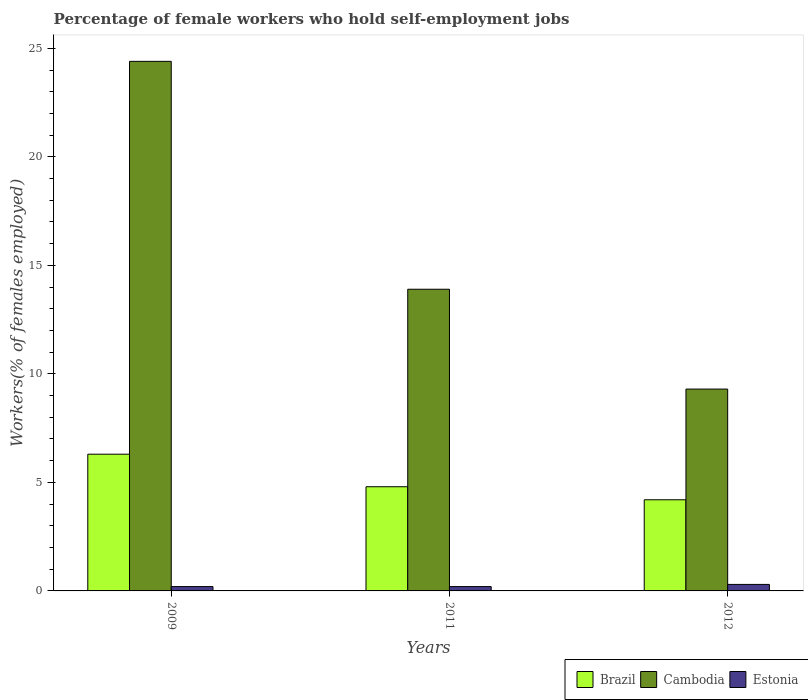How many different coloured bars are there?
Provide a succinct answer. 3. How many groups of bars are there?
Your response must be concise. 3. How many bars are there on the 2nd tick from the left?
Ensure brevity in your answer.  3. What is the percentage of self-employed female workers in Cambodia in 2011?
Give a very brief answer. 13.9. Across all years, what is the maximum percentage of self-employed female workers in Brazil?
Ensure brevity in your answer.  6.3. Across all years, what is the minimum percentage of self-employed female workers in Estonia?
Keep it short and to the point. 0.2. In which year was the percentage of self-employed female workers in Estonia maximum?
Offer a terse response. 2012. In which year was the percentage of self-employed female workers in Brazil minimum?
Offer a very short reply. 2012. What is the total percentage of self-employed female workers in Cambodia in the graph?
Your answer should be compact. 47.6. What is the difference between the percentage of self-employed female workers in Brazil in 2011 and that in 2012?
Make the answer very short. 0.6. What is the difference between the percentage of self-employed female workers in Brazil in 2009 and the percentage of self-employed female workers in Cambodia in 2012?
Make the answer very short. -3. What is the average percentage of self-employed female workers in Estonia per year?
Provide a succinct answer. 0.23. In the year 2011, what is the difference between the percentage of self-employed female workers in Estonia and percentage of self-employed female workers in Brazil?
Provide a short and direct response. -4.6. In how many years, is the percentage of self-employed female workers in Estonia greater than 23 %?
Your response must be concise. 0. What is the ratio of the percentage of self-employed female workers in Estonia in 2011 to that in 2012?
Provide a succinct answer. 0.67. Is the percentage of self-employed female workers in Cambodia in 2011 less than that in 2012?
Your response must be concise. No. Is the difference between the percentage of self-employed female workers in Estonia in 2011 and 2012 greater than the difference between the percentage of self-employed female workers in Brazil in 2011 and 2012?
Your response must be concise. No. What is the difference between the highest and the second highest percentage of self-employed female workers in Brazil?
Provide a short and direct response. 1.5. What is the difference between the highest and the lowest percentage of self-employed female workers in Cambodia?
Ensure brevity in your answer.  15.1. Is the sum of the percentage of self-employed female workers in Estonia in 2011 and 2012 greater than the maximum percentage of self-employed female workers in Brazil across all years?
Provide a short and direct response. No. What does the 3rd bar from the left in 2011 represents?
Ensure brevity in your answer.  Estonia. What does the 3rd bar from the right in 2009 represents?
Offer a terse response. Brazil. Are all the bars in the graph horizontal?
Ensure brevity in your answer.  No. How many years are there in the graph?
Offer a very short reply. 3. What is the difference between two consecutive major ticks on the Y-axis?
Offer a terse response. 5. Are the values on the major ticks of Y-axis written in scientific E-notation?
Ensure brevity in your answer.  No. Does the graph contain grids?
Your response must be concise. No. Where does the legend appear in the graph?
Offer a very short reply. Bottom right. How are the legend labels stacked?
Your answer should be very brief. Horizontal. What is the title of the graph?
Your response must be concise. Percentage of female workers who hold self-employment jobs. What is the label or title of the Y-axis?
Give a very brief answer. Workers(% of females employed). What is the Workers(% of females employed) in Brazil in 2009?
Keep it short and to the point. 6.3. What is the Workers(% of females employed) of Cambodia in 2009?
Your answer should be very brief. 24.4. What is the Workers(% of females employed) of Estonia in 2009?
Give a very brief answer. 0.2. What is the Workers(% of females employed) of Brazil in 2011?
Make the answer very short. 4.8. What is the Workers(% of females employed) in Cambodia in 2011?
Your answer should be very brief. 13.9. What is the Workers(% of females employed) in Estonia in 2011?
Make the answer very short. 0.2. What is the Workers(% of females employed) in Brazil in 2012?
Your answer should be very brief. 4.2. What is the Workers(% of females employed) of Cambodia in 2012?
Your answer should be very brief. 9.3. What is the Workers(% of females employed) of Estonia in 2012?
Keep it short and to the point. 0.3. Across all years, what is the maximum Workers(% of females employed) in Brazil?
Provide a short and direct response. 6.3. Across all years, what is the maximum Workers(% of females employed) in Cambodia?
Offer a terse response. 24.4. Across all years, what is the maximum Workers(% of females employed) in Estonia?
Ensure brevity in your answer.  0.3. Across all years, what is the minimum Workers(% of females employed) in Brazil?
Make the answer very short. 4.2. Across all years, what is the minimum Workers(% of females employed) in Cambodia?
Provide a succinct answer. 9.3. Across all years, what is the minimum Workers(% of females employed) in Estonia?
Offer a very short reply. 0.2. What is the total Workers(% of females employed) of Cambodia in the graph?
Provide a short and direct response. 47.6. What is the total Workers(% of females employed) of Estonia in the graph?
Provide a short and direct response. 0.7. What is the difference between the Workers(% of females employed) in Cambodia in 2009 and that in 2011?
Ensure brevity in your answer.  10.5. What is the difference between the Workers(% of females employed) of Brazil in 2009 and that in 2012?
Provide a succinct answer. 2.1. What is the difference between the Workers(% of females employed) in Estonia in 2009 and that in 2012?
Give a very brief answer. -0.1. What is the difference between the Workers(% of females employed) of Brazil in 2011 and that in 2012?
Make the answer very short. 0.6. What is the difference between the Workers(% of females employed) of Brazil in 2009 and the Workers(% of females employed) of Cambodia in 2011?
Provide a short and direct response. -7.6. What is the difference between the Workers(% of females employed) of Cambodia in 2009 and the Workers(% of females employed) of Estonia in 2011?
Ensure brevity in your answer.  24.2. What is the difference between the Workers(% of females employed) of Brazil in 2009 and the Workers(% of females employed) of Cambodia in 2012?
Offer a terse response. -3. What is the difference between the Workers(% of females employed) of Cambodia in 2009 and the Workers(% of females employed) of Estonia in 2012?
Your answer should be very brief. 24.1. What is the difference between the Workers(% of females employed) in Brazil in 2011 and the Workers(% of females employed) in Cambodia in 2012?
Offer a terse response. -4.5. What is the difference between the Workers(% of females employed) in Cambodia in 2011 and the Workers(% of females employed) in Estonia in 2012?
Make the answer very short. 13.6. What is the average Workers(% of females employed) in Brazil per year?
Offer a terse response. 5.1. What is the average Workers(% of females employed) in Cambodia per year?
Provide a succinct answer. 15.87. What is the average Workers(% of females employed) of Estonia per year?
Give a very brief answer. 0.23. In the year 2009, what is the difference between the Workers(% of females employed) in Brazil and Workers(% of females employed) in Cambodia?
Your response must be concise. -18.1. In the year 2009, what is the difference between the Workers(% of females employed) of Cambodia and Workers(% of females employed) of Estonia?
Ensure brevity in your answer.  24.2. In the year 2011, what is the difference between the Workers(% of females employed) of Brazil and Workers(% of females employed) of Estonia?
Offer a very short reply. 4.6. In the year 2012, what is the difference between the Workers(% of females employed) of Brazil and Workers(% of females employed) of Cambodia?
Offer a very short reply. -5.1. In the year 2012, what is the difference between the Workers(% of females employed) in Brazil and Workers(% of females employed) in Estonia?
Your answer should be very brief. 3.9. What is the ratio of the Workers(% of females employed) in Brazil in 2009 to that in 2011?
Make the answer very short. 1.31. What is the ratio of the Workers(% of females employed) of Cambodia in 2009 to that in 2011?
Give a very brief answer. 1.76. What is the ratio of the Workers(% of females employed) in Estonia in 2009 to that in 2011?
Ensure brevity in your answer.  1. What is the ratio of the Workers(% of females employed) of Brazil in 2009 to that in 2012?
Offer a terse response. 1.5. What is the ratio of the Workers(% of females employed) of Cambodia in 2009 to that in 2012?
Make the answer very short. 2.62. What is the ratio of the Workers(% of females employed) of Brazil in 2011 to that in 2012?
Your response must be concise. 1.14. What is the ratio of the Workers(% of females employed) of Cambodia in 2011 to that in 2012?
Your response must be concise. 1.49. What is the ratio of the Workers(% of females employed) in Estonia in 2011 to that in 2012?
Your response must be concise. 0.67. What is the difference between the highest and the second highest Workers(% of females employed) of Brazil?
Provide a short and direct response. 1.5. What is the difference between the highest and the second highest Workers(% of females employed) in Cambodia?
Keep it short and to the point. 10.5. What is the difference between the highest and the lowest Workers(% of females employed) of Brazil?
Your answer should be compact. 2.1. What is the difference between the highest and the lowest Workers(% of females employed) in Cambodia?
Your answer should be very brief. 15.1. 